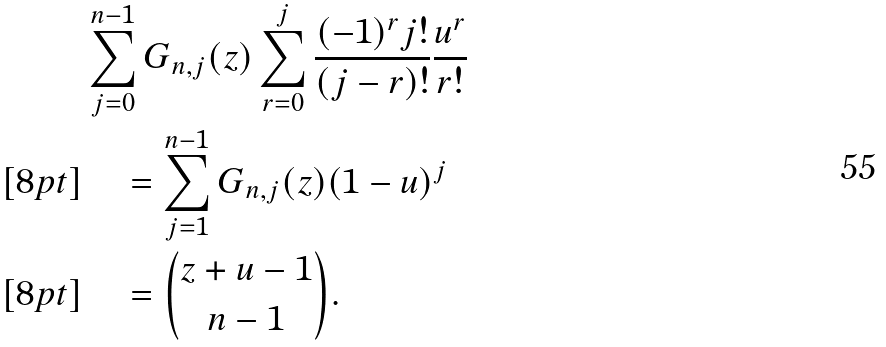<formula> <loc_0><loc_0><loc_500><loc_500>& \sum _ { j = 0 } ^ { n - 1 } G _ { n , j } ( z ) \sum _ { r = 0 } ^ { j } \frac { ( - 1 ) ^ { r } j ! } { ( j - r ) ! } \frac { u ^ { r } } { r ! } \\ [ 8 p t ] & \quad = \sum _ { j = 1 } ^ { n - 1 } G _ { n , j } ( z ) ( 1 - u ) ^ { j } \\ [ 8 p t ] & \quad = \binom { z + u - 1 } { n - 1 } .</formula> 